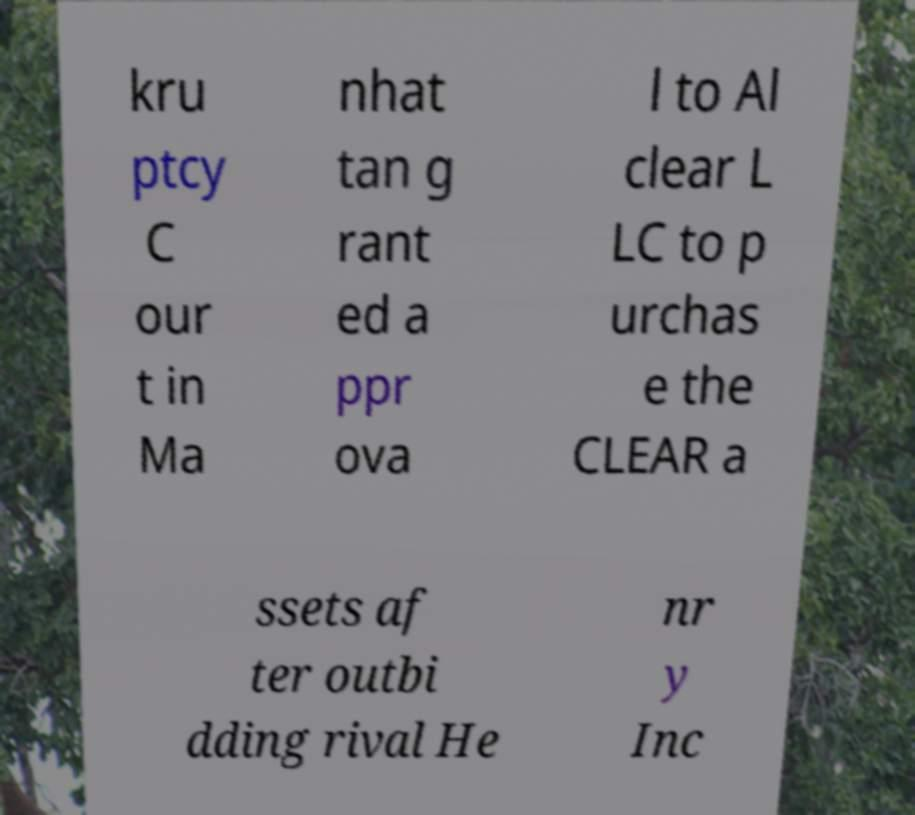For documentation purposes, I need the text within this image transcribed. Could you provide that? kru ptcy C our t in Ma nhat tan g rant ed a ppr ova l to Al clear L LC to p urchas e the CLEAR a ssets af ter outbi dding rival He nr y Inc 